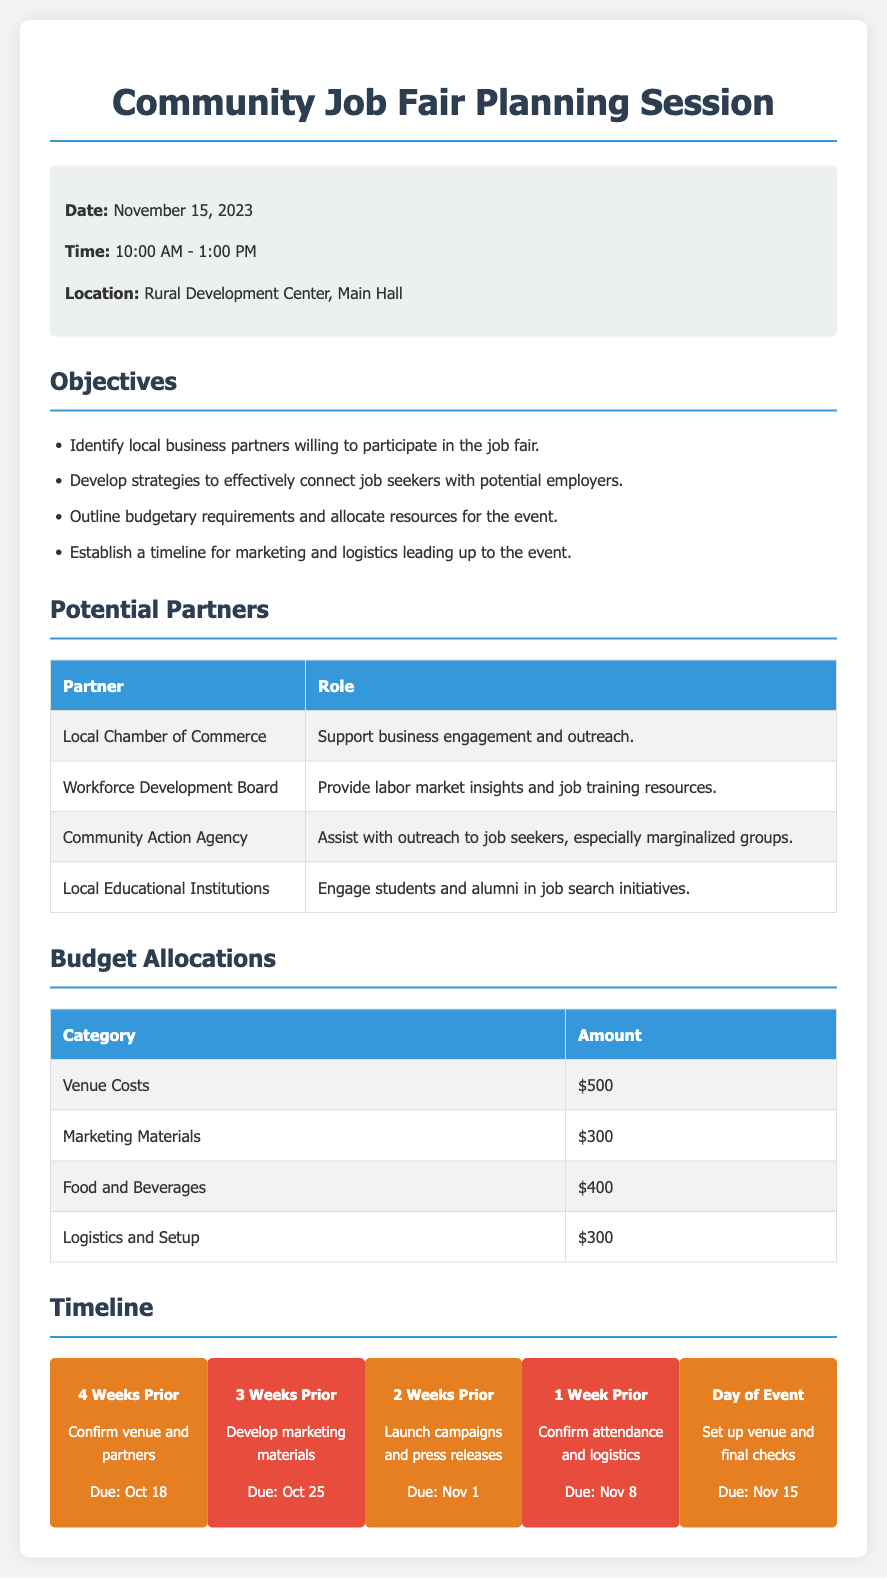What is the date of the event? The date of the event is listed in the document under event details.
Answer: November 15, 2023 What time is the Community Job Fair scheduled? The time is specified in the event details section of the document.
Answer: 10:00 AM - 1:00 PM Where will the event be held? The location is provided under the event details section.
Answer: Rural Development Center, Main Hall How much is allocated for Marketing Materials? The budget allocations table shows the amount for this category.
Answer: $300 What is one objective of the job fair? The objectives section lists several specific goals for the event.
Answer: Identify local business partners willing to participate in the job fair Which organization will provide labor market insights? The potential partners table specifies organizations and their roles.
Answer: Workforce Development Board When is the confirmation of venue and partners due? The timeline section outlines deadlines for various tasks leading up to the event.
Answer: Oct 18 What is the budget for Food and Beverages? The budget allocations table specifies amounts for different categories.
Answer: $400 What action needs to be taken 2 weeks prior to the event? The timeline item provides information on specific tasks to be completed at that time.
Answer: Launch campaigns and press releases 